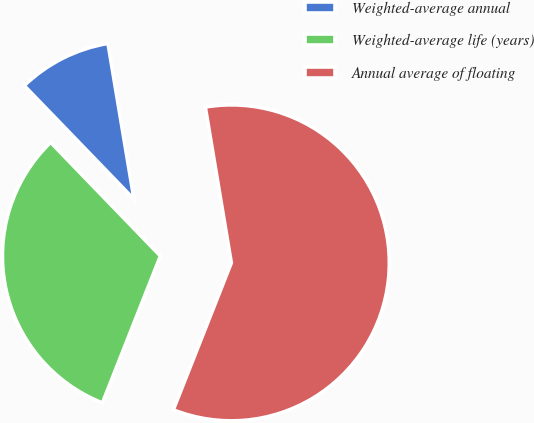Convert chart. <chart><loc_0><loc_0><loc_500><loc_500><pie_chart><fcel>Weighted-average annual<fcel>Weighted-average life (years)<fcel>Annual average of floating<nl><fcel>9.59%<fcel>31.79%<fcel>58.61%<nl></chart> 